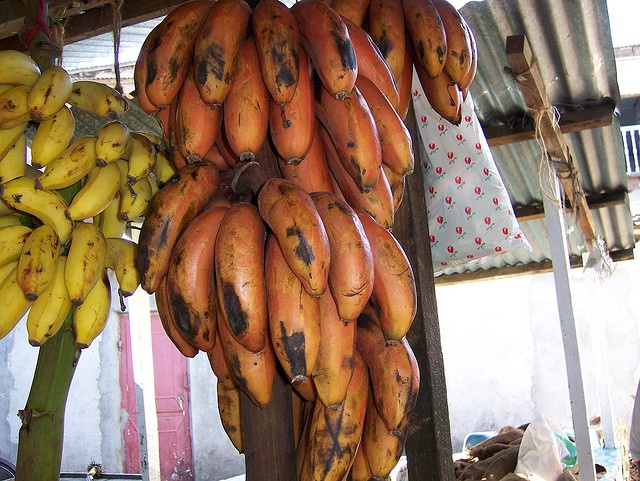Describe the objects in this image and their specific colors. I can see banana in black, brown, maroon, and tan tones and banana in black, olive, and gold tones in this image. 